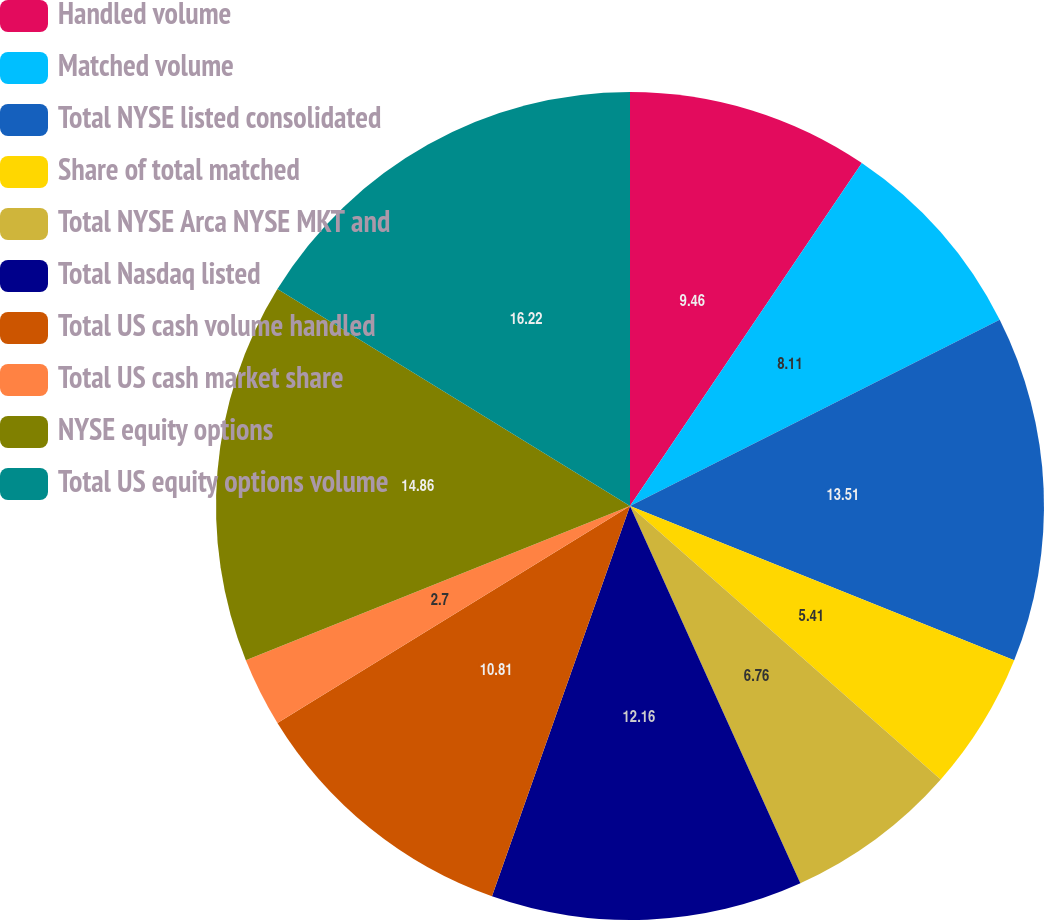Convert chart. <chart><loc_0><loc_0><loc_500><loc_500><pie_chart><fcel>Handled volume<fcel>Matched volume<fcel>Total NYSE listed consolidated<fcel>Share of total matched<fcel>Total NYSE Arca NYSE MKT and<fcel>Total Nasdaq listed<fcel>Total US cash volume handled<fcel>Total US cash market share<fcel>NYSE equity options<fcel>Total US equity options volume<nl><fcel>9.46%<fcel>8.11%<fcel>13.51%<fcel>5.41%<fcel>6.76%<fcel>12.16%<fcel>10.81%<fcel>2.7%<fcel>14.86%<fcel>16.22%<nl></chart> 